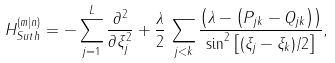Convert formula to latex. <formula><loc_0><loc_0><loc_500><loc_500>H ^ { ( m | n ) } _ { S u t h } = - \sum _ { j = 1 } ^ { L } \frac { \partial ^ { 2 } } { \partial { \xi } _ { j } ^ { 2 } } + \frac { \lambda } { 2 } \, \sum _ { j < k } \frac { \left ( \lambda - \left ( P _ { j k } - Q _ { j k } \right ) \right ) } { \sin ^ { 2 } \left [ ( { \xi } _ { j } - { \xi } _ { k } ) / 2 \right ] } ,</formula> 